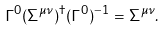<formula> <loc_0><loc_0><loc_500><loc_500>\Gamma ^ { 0 } ( \Sigma ^ { \mu \nu } ) ^ { \dagger } ( \Gamma ^ { 0 } ) ^ { - 1 } = \Sigma ^ { \mu \nu } .</formula> 